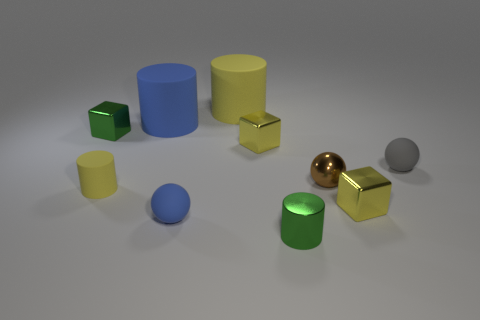Can you describe the objects that have a circular base? Sure, there are four objects in the image with a circular base: one dark blue cylinder, one gold cylinder, and two spheres—one gold and the other silver. What's the relative size of the two cylinders? The dark blue cylinder is taller and wider than the gold cylinder, making the blue one the larger of the two. 